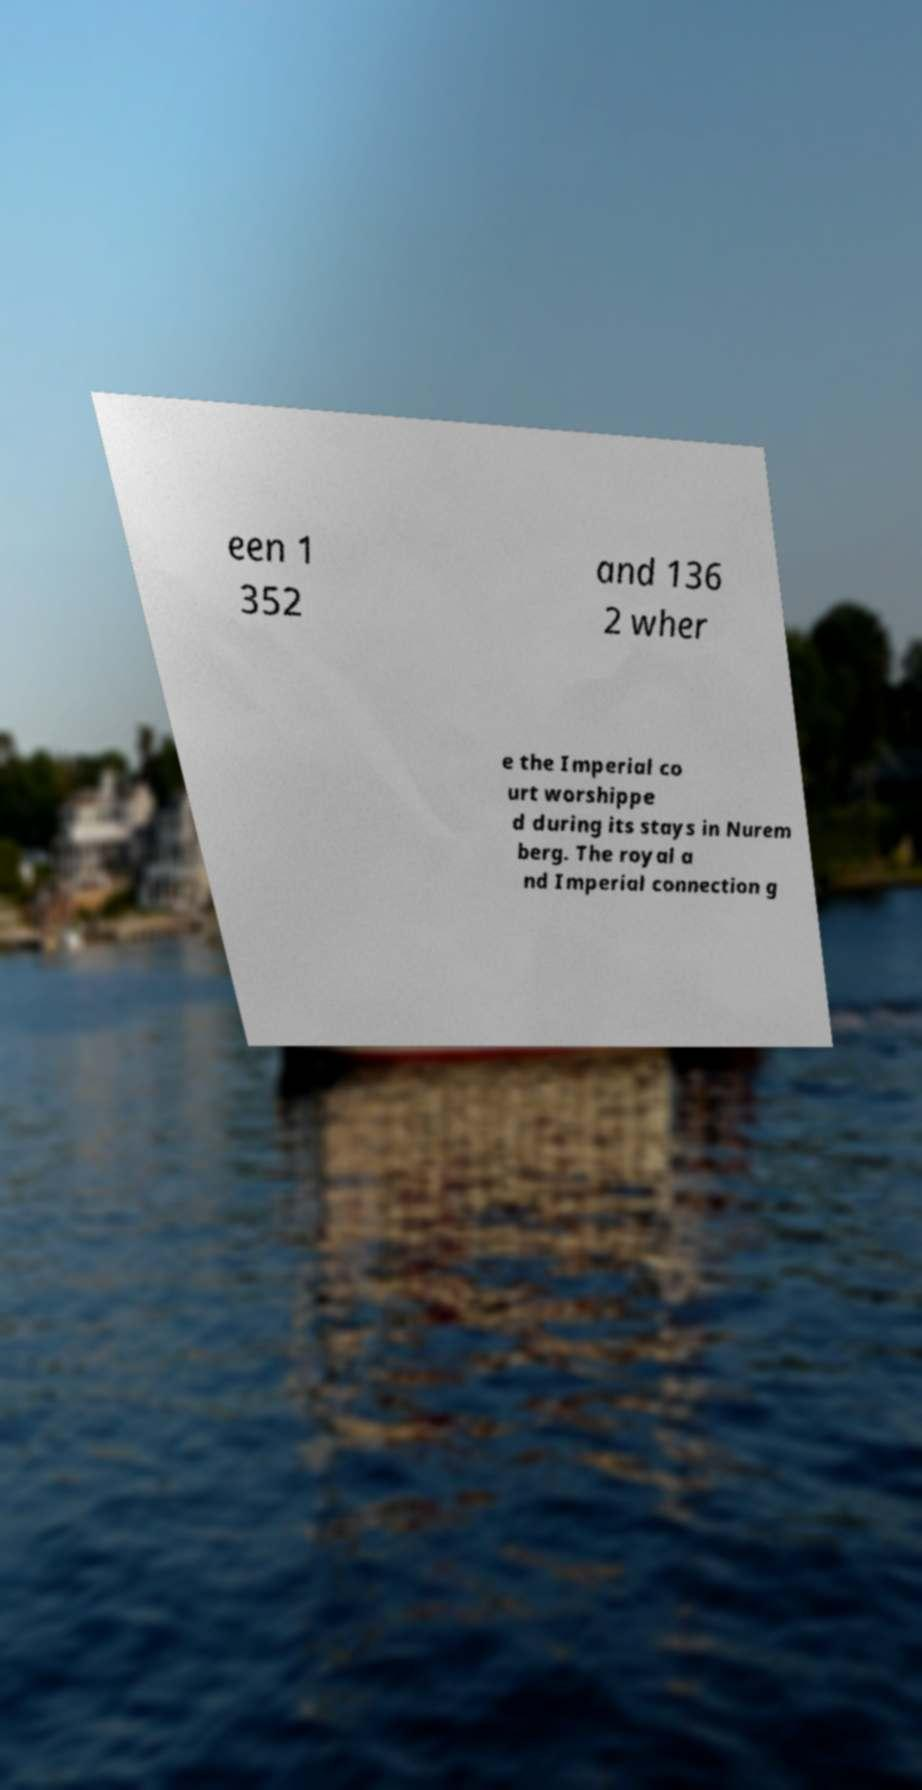Could you extract and type out the text from this image? een 1 352 and 136 2 wher e the Imperial co urt worshippe d during its stays in Nurem berg. The royal a nd Imperial connection g 